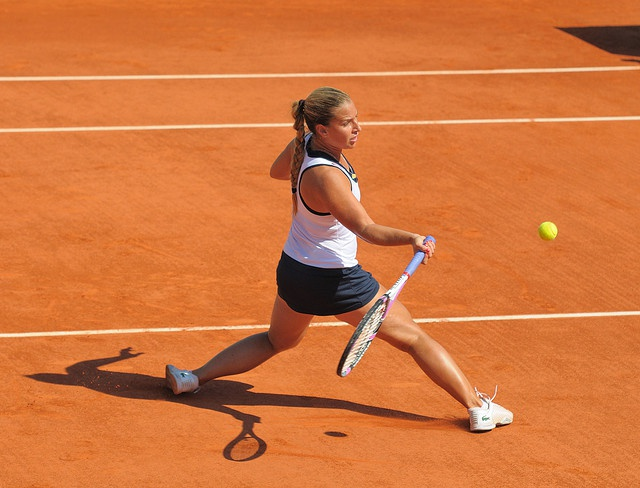Describe the objects in this image and their specific colors. I can see people in salmon, black, maroon, tan, and brown tones, tennis racket in salmon, ivory, gray, darkgray, and tan tones, and sports ball in salmon, khaki, yellow, and olive tones in this image. 